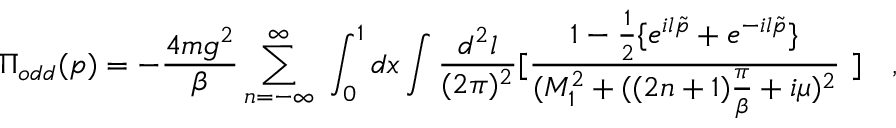<formula> <loc_0><loc_0><loc_500><loc_500>\Pi _ { o d d } ( p ) = - \frac { 4 m g ^ { 2 } } { \beta } \sum _ { n = - \infty } ^ { \infty } \int _ { 0 } ^ { 1 } d x \int \frac { d ^ { 2 } l } { ( 2 \pi ) ^ { 2 } } [ \frac { 1 - \frac { 1 } { 2 } \{ e ^ { i l \tilde { p } } + e ^ { - i l \tilde { p } } \} } { ( M _ { 1 } ^ { 2 } + ( ( 2 n + 1 ) \frac { \pi } { \beta } + i \mu ) ^ { 2 } } ] ,</formula> 